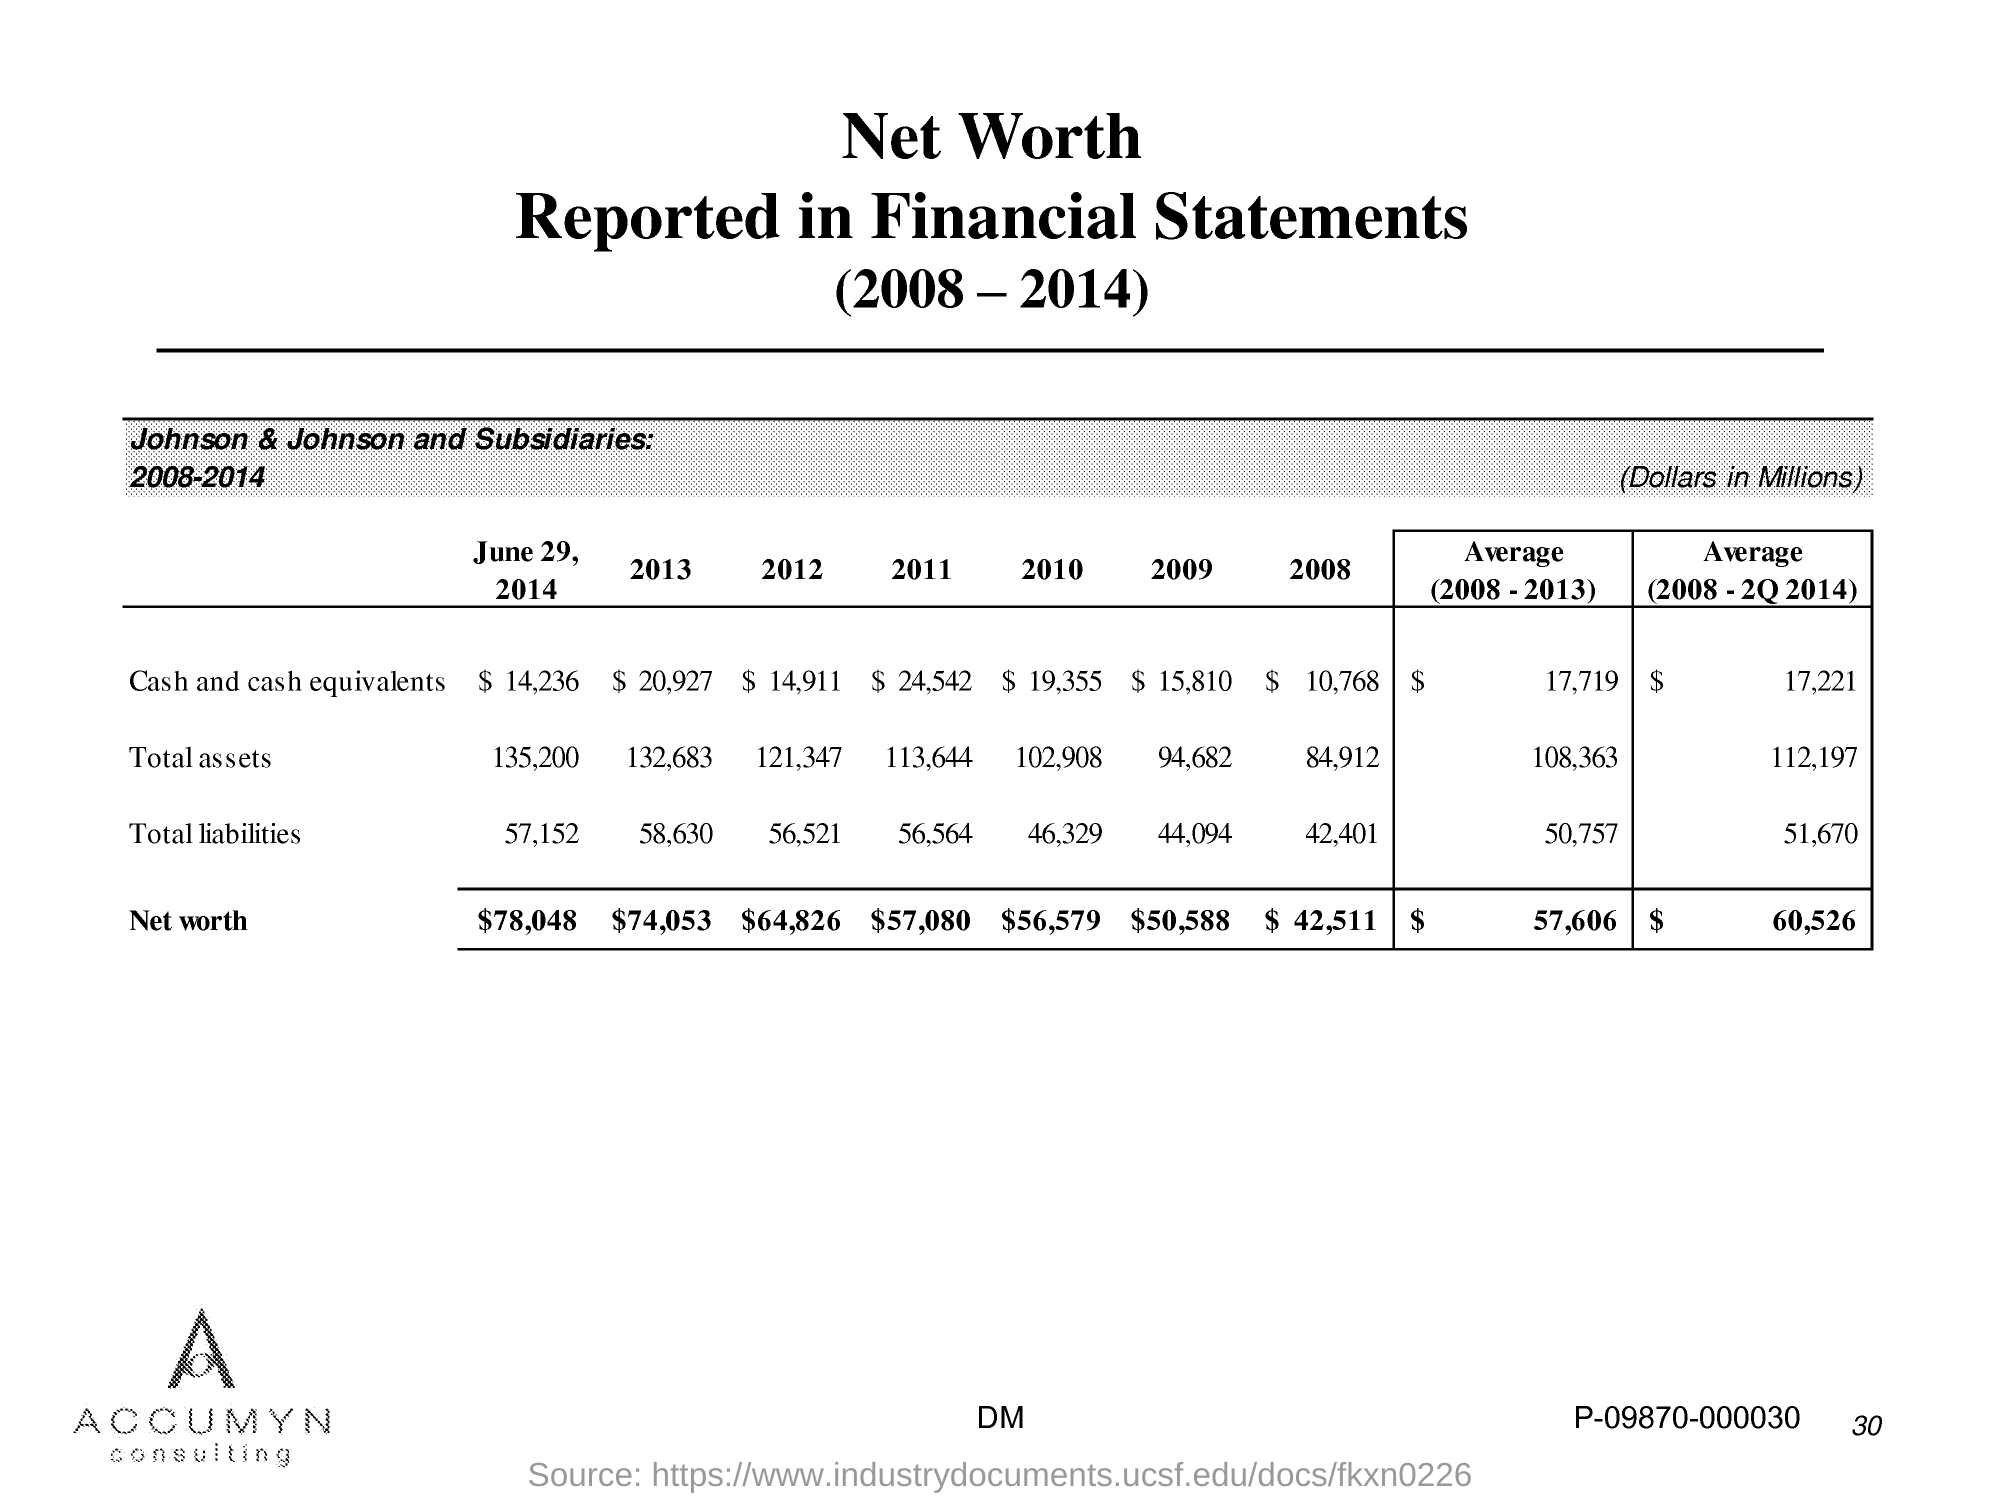What does the trend in cash and cash equivalents from 2008 to 2014 tell us? From 2008 to 2014, the cash and cash equivalents for Johnson & Johnson show a varied trend. Starting at $10,768 million in 2008, there's a notable increase peaking at $25,442 million in 2011, followed by a decrease and fluctuations, ending with $14,236 million in 2014. The peak in 2011 could indicate strategic cash reserves or savings, while the later years show a reallocation or investment of those funds. 